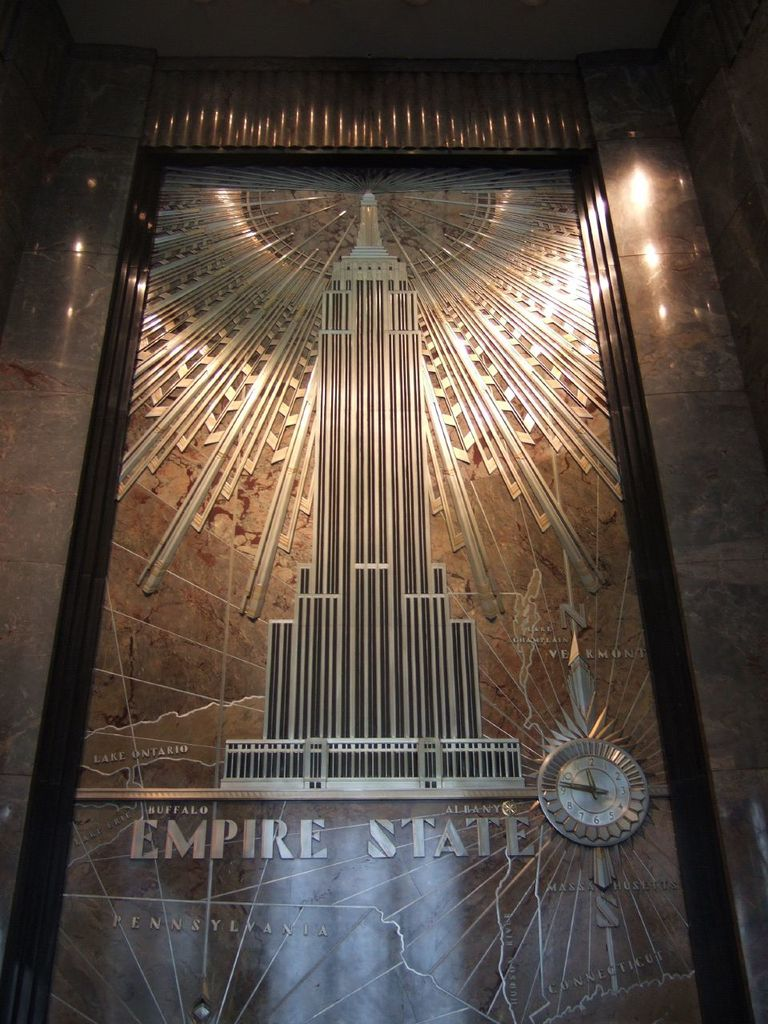What architectural style is demonstrated in the lobby decoration of this image? The lobby decoration in the image showcases an Art Deco style, characterized by its geometric patterns, rich materials, and elaborate ornamentation. 